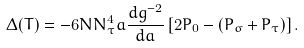<formula> <loc_0><loc_0><loc_500><loc_500>\Delta ( T ) = - 6 N { N ^ { 4 } _ { \tau } } a \frac { d g ^ { - 2 } } { d a } \left [ 2 P _ { 0 } - ( P _ { \sigma } + P _ { \tau } ) \right ] .</formula> 